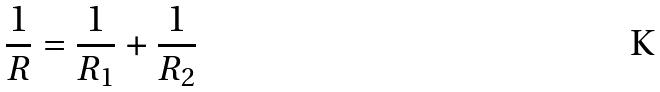Convert formula to latex. <formula><loc_0><loc_0><loc_500><loc_500>\frac { 1 } { R } = \frac { 1 } { R _ { 1 } } + \frac { 1 } { R _ { 2 } }</formula> 